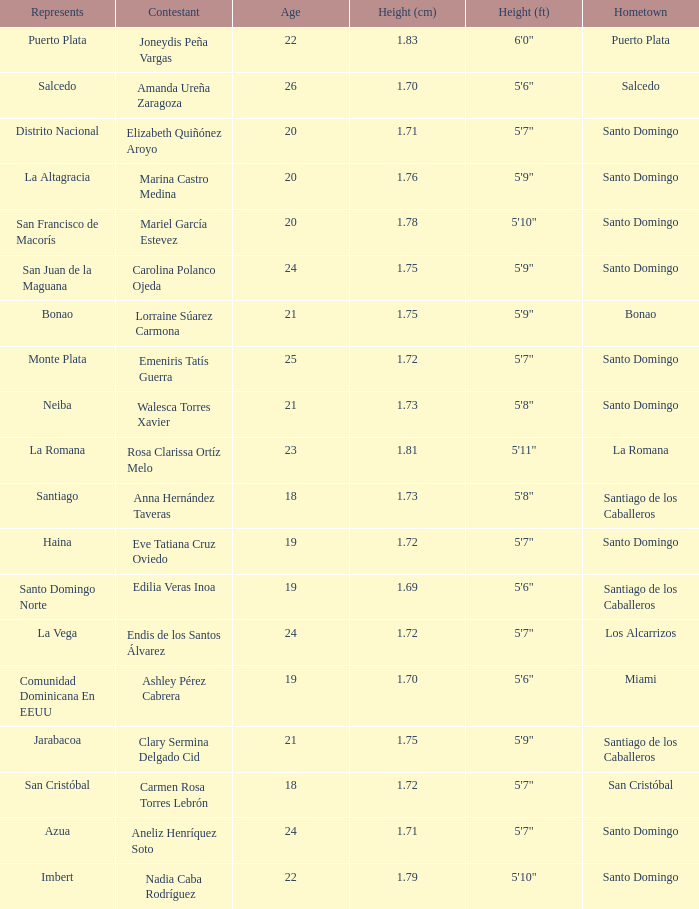Name the most age 26.0. 